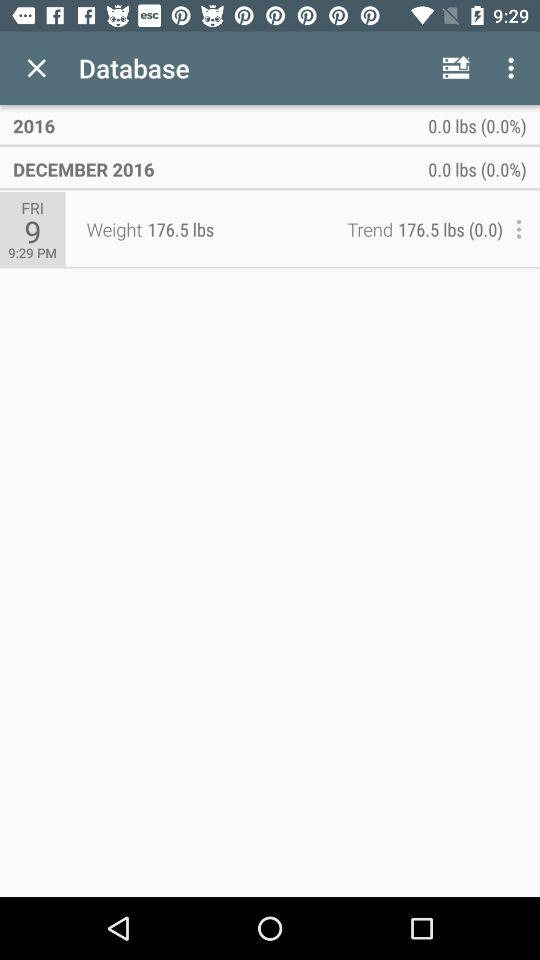What is the unit of weight? The unit of weight is pounds. 